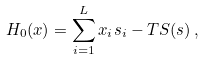Convert formula to latex. <formula><loc_0><loc_0><loc_500><loc_500>H _ { 0 } ( { x } ) = \sum _ { i = 1 } ^ { L } x _ { i } s _ { i } - T S ( { s } ) \, ,</formula> 